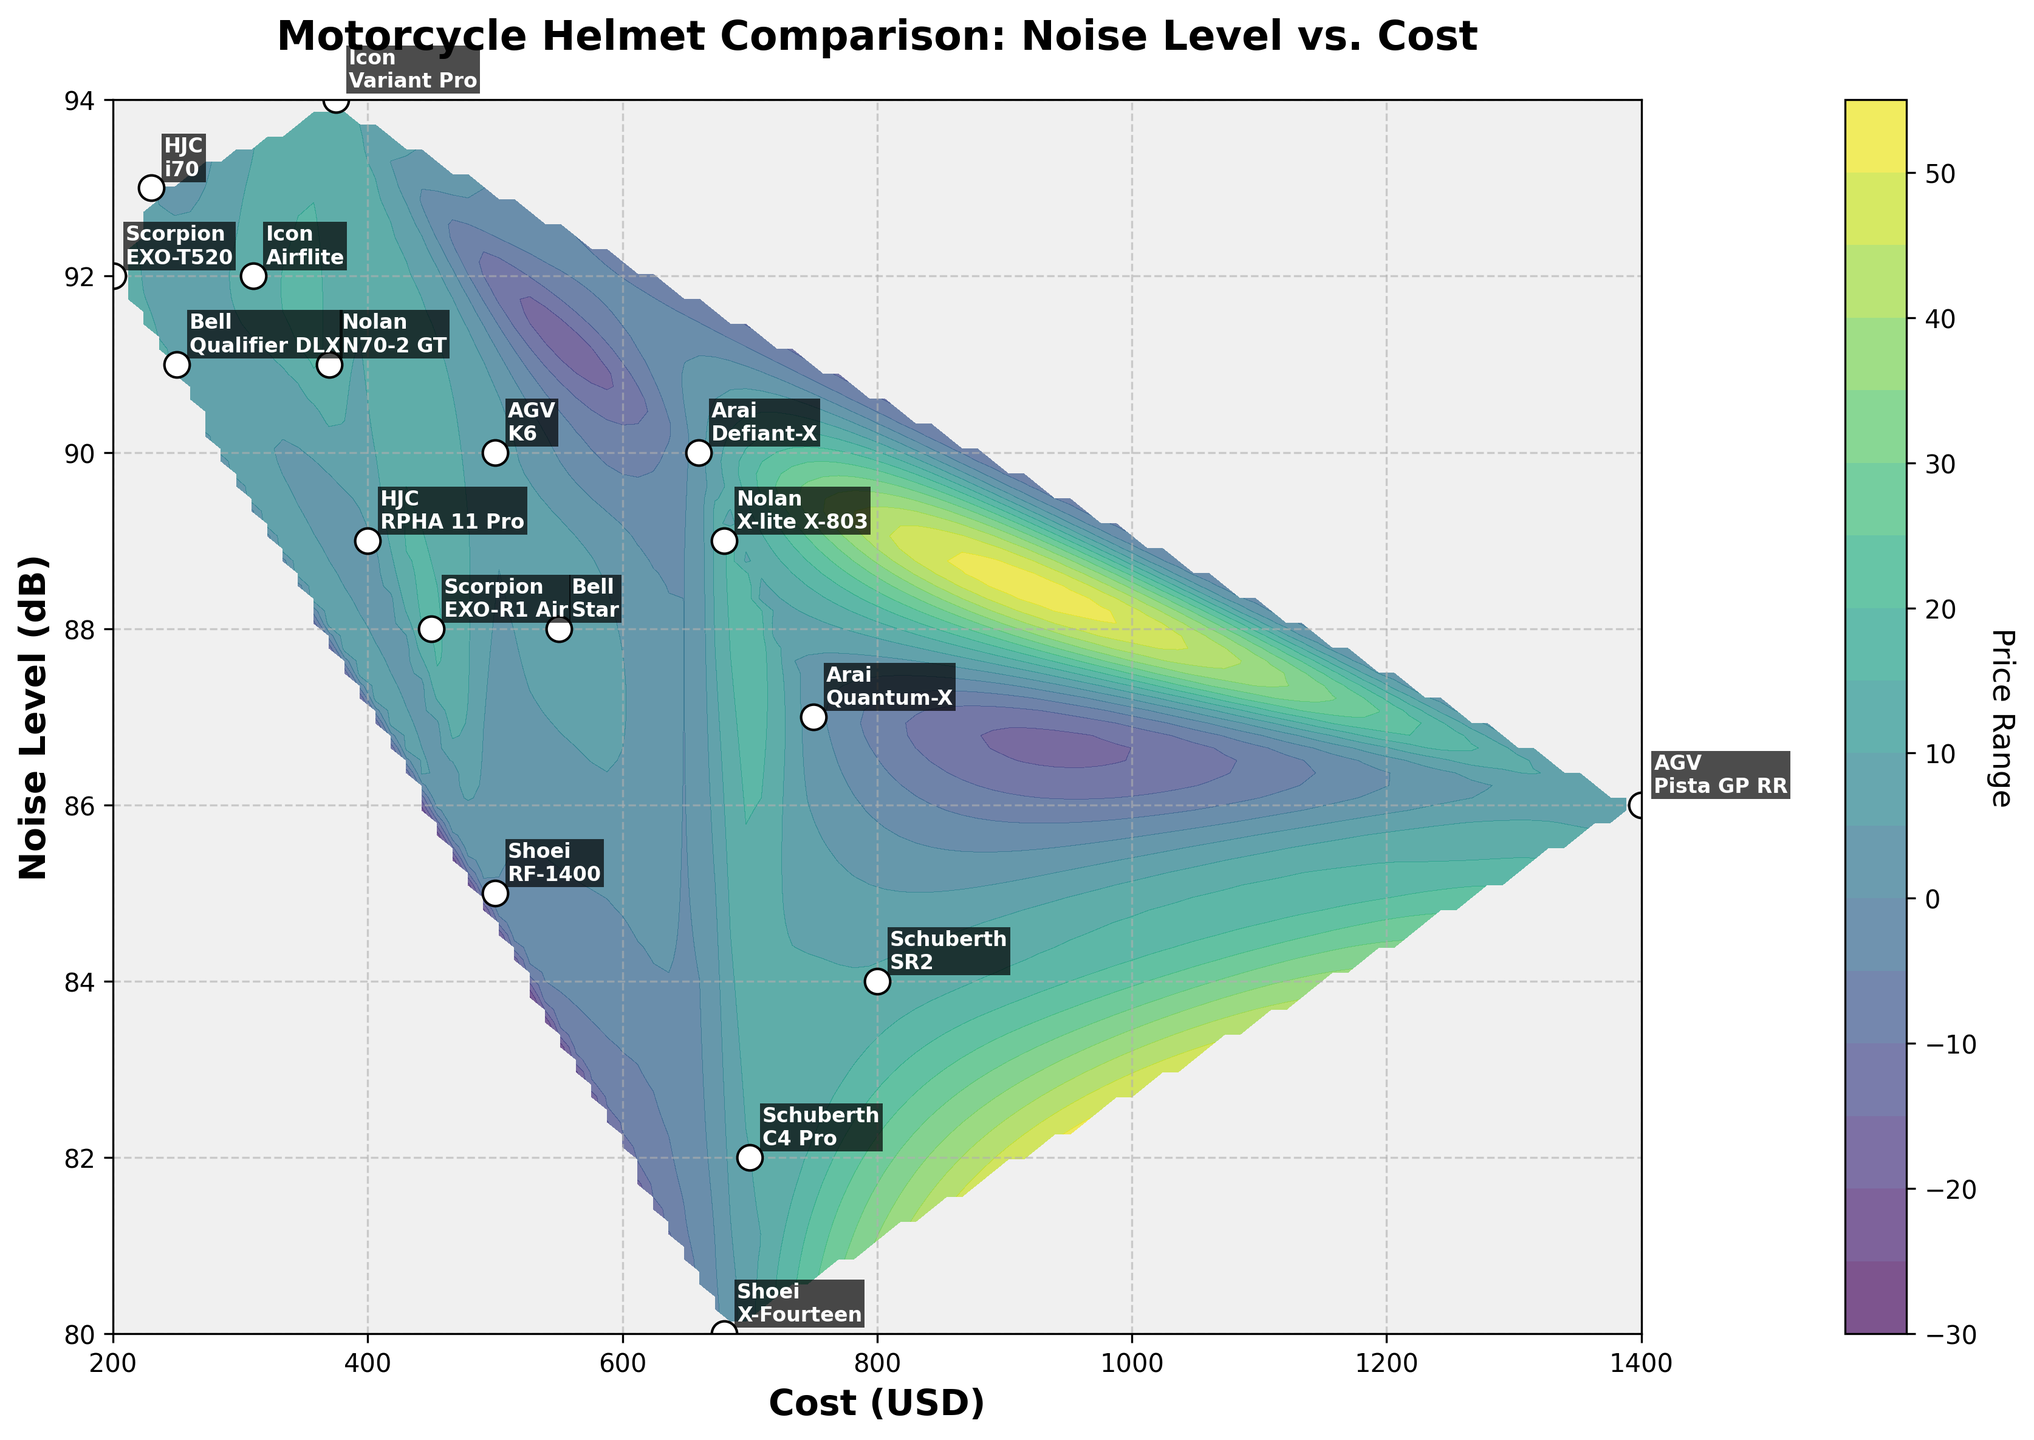what's the title of the plot? The title of a plot is usually found at the top center of the figure. In this case, the title clearly states "Motorcycle Helmet Comparison: Noise Level vs. Cost".
Answer: Motorcycle Helmet Comparison: Noise Level vs. Cost how many different brands of motorcycle helmets are shown in the plot? To find the number of different brands, look for unique brand names in the plot's annotations. There are 7 different brands: Shoei, Arai, HJC, AGV, Bell, Schuberth, Icon, Nolan, and Scorpion.
Answer: 9 which helmet model has the highest noise level and what is its cost? To identify the helmet with the highest noise level, look for the highest y-value (Noise Level) on the plot. The Icon Variant Pro has the highest noise level at 94 dB, and its cost is $375.
Answer: Icon Variant Pro at $375 comparing Shoei and Schuberth helmets, which brand generally has lower noise levels for similar cost ranges? To compare Shoeis’s and Schuberth’s helmets, look at the annotated data points for these two brands and observe their positions. Schuberth helmets (82 dB, $700 and 84 dB, $800) generally have lower noise levels compared to Shoei helmets (85 dB, $500 and 80 dB, $680) for similar cost ranges.
Answer: Schuberth which helmet is the most expensive and what's its noise level? To determine the most expensive helmet, look for the highest x-value (Cost) on the plot. The AGV Pista GP RR is the most expensive at $1400, and its noise level is 86 dB.
Answer: AGV Pista GP RR at 86 dB what's the trend between noise level and cost for AGV helmets? Look for the AGV helmets' data points. AGV's Pista GP RR (86 dB, $1400) and K6 (90 dB, $500) show that as the cost increases, the noise level tends to decrease for AGV helmets.
Answer: As cost increases, noise level decreases for AGV what's the median noise level of all the helmets? To find the median noise level, list all the noise levels and find the middle value. Noise levels are [80, 82, 84, 85, 86, 87, 88, 88, 89, 89, 90, 90, 91, 91, 92, 92, 93, 94]. The median value is in the middle of this sorted list, which is 89 dB.
Answer: 89 dB which helmet brand has the largest variation in noise levels among its models? Look at the range of noise levels for each brand. For HJC, the noise levels are 89 dB and 93 dB. For Icon, they are 92 dB and 94 dB. The largest variation (94 - 92) - (93 - 89) = 2 is for Icon.
Answer: Icon which helmets cost less than $300 and what are their noise levels? Identify helmets with costs less than $300 by looking at the points between $200 and $300 on the x-axis.  HJC i70 (93 dB), Bell Qualifier DLX (91 dB), Icon Airflite (92 dB), and Scorpion EXO-T520 (92 dB).
Answer: HJC i70: 93 dB, Bell Qualifier DLX: 91 dB, Icon Airflite: 92 dB, Scorpion EXO-T520: 92 dB 